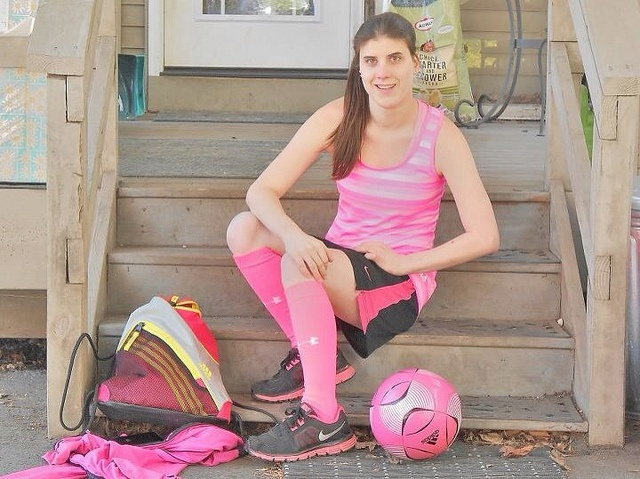Describe the objects in this image and their specific colors. I can see people in gainsboro, lightpink, gray, and tan tones, backpack in gainsboro, brown, gray, lightgray, and khaki tones, and sports ball in gainsboro, lightpink, violet, and lavender tones in this image. 